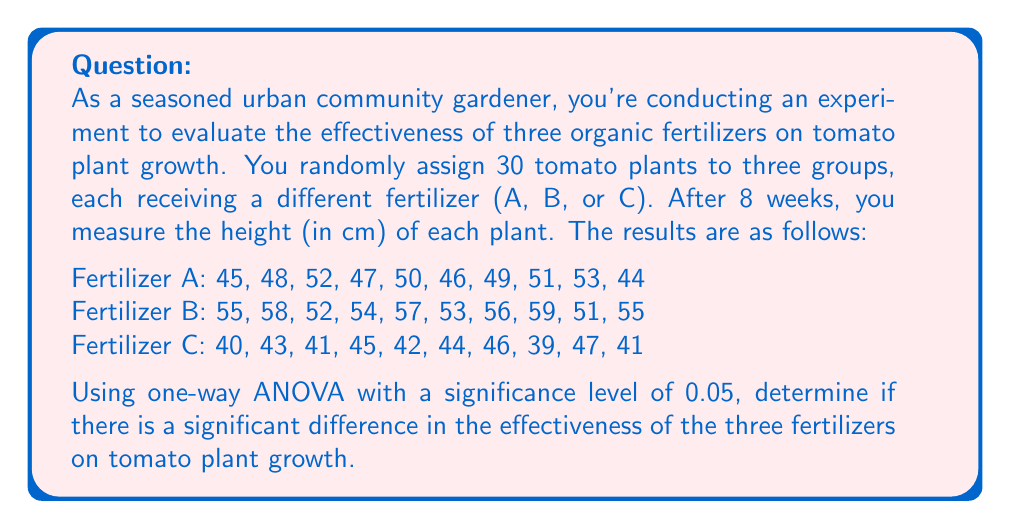Give your solution to this math problem. To solve this problem using one-way ANOVA, we'll follow these steps:

1. Calculate the sum of squares between groups (SSB), within groups (SSW), and total (SST).
2. Calculate the degrees of freedom for between groups (dfB), within groups (dfW), and total (dfT).
3. Calculate the mean square between groups (MSB) and within groups (MSW).
4. Calculate the F-statistic.
5. Compare the F-statistic to the critical F-value.

Step 1: Calculate sums of squares

First, we need to calculate the grand mean:
$$ \bar{X} = \frac{\sum_{i=1}^{n} X_i}{N} = \frac{1373}{30} = 45.77 $$

Now, we can calculate SSB, SSW, and SST:

SSB:
$$ SSB = \sum_{i=1}^{k} n_i(\bar{X}_i - \bar{X})^2 $$
$$ SSB = 10(48.5 - 45.77)^2 + 10(55 - 45.77)^2 + 10(42.8 - 45.77)^2 = 828.87 $$

SSW:
$$ SSW = \sum_{i=1}^{k} \sum_{j=1}^{n_i} (X_{ij} - \bar{X}_i)^2 $$
$$ SSW = 102.5 + 70 + 70.6 = 243.1 $$

SST:
$$ SST = SSB + SSW = 828.87 + 243.1 = 1071.97 $$

Step 2: Calculate degrees of freedom

dfB = k - 1 = 3 - 1 = 2
dfW = N - k = 30 - 3 = 27
dfT = N - 1 = 30 - 1 = 29

Step 3: Calculate mean squares

$$ MSB = \frac{SSB}{dfB} = \frac{828.87}{2} = 414.435 $$
$$ MSW = \frac{SSW}{dfW} = \frac{243.1}{27} = 9.004 $$

Step 4: Calculate F-statistic

$$ F = \frac{MSB}{MSW} = \frac{414.435}{9.004} = 46.03 $$

Step 5: Compare F-statistic to critical F-value

The critical F-value for α = 0.05, dfB = 2, and dfW = 27 is approximately 3.35.

Since our calculated F-statistic (46.03) is greater than the critical F-value (3.35), we reject the null hypothesis.
Answer: There is a significant difference in the effectiveness of the three fertilizers on tomato plant growth (F(2, 27) = 46.03, p < 0.05). This suggests that at least one of the fertilizers has a significantly different effect on plant growth compared to the others. 